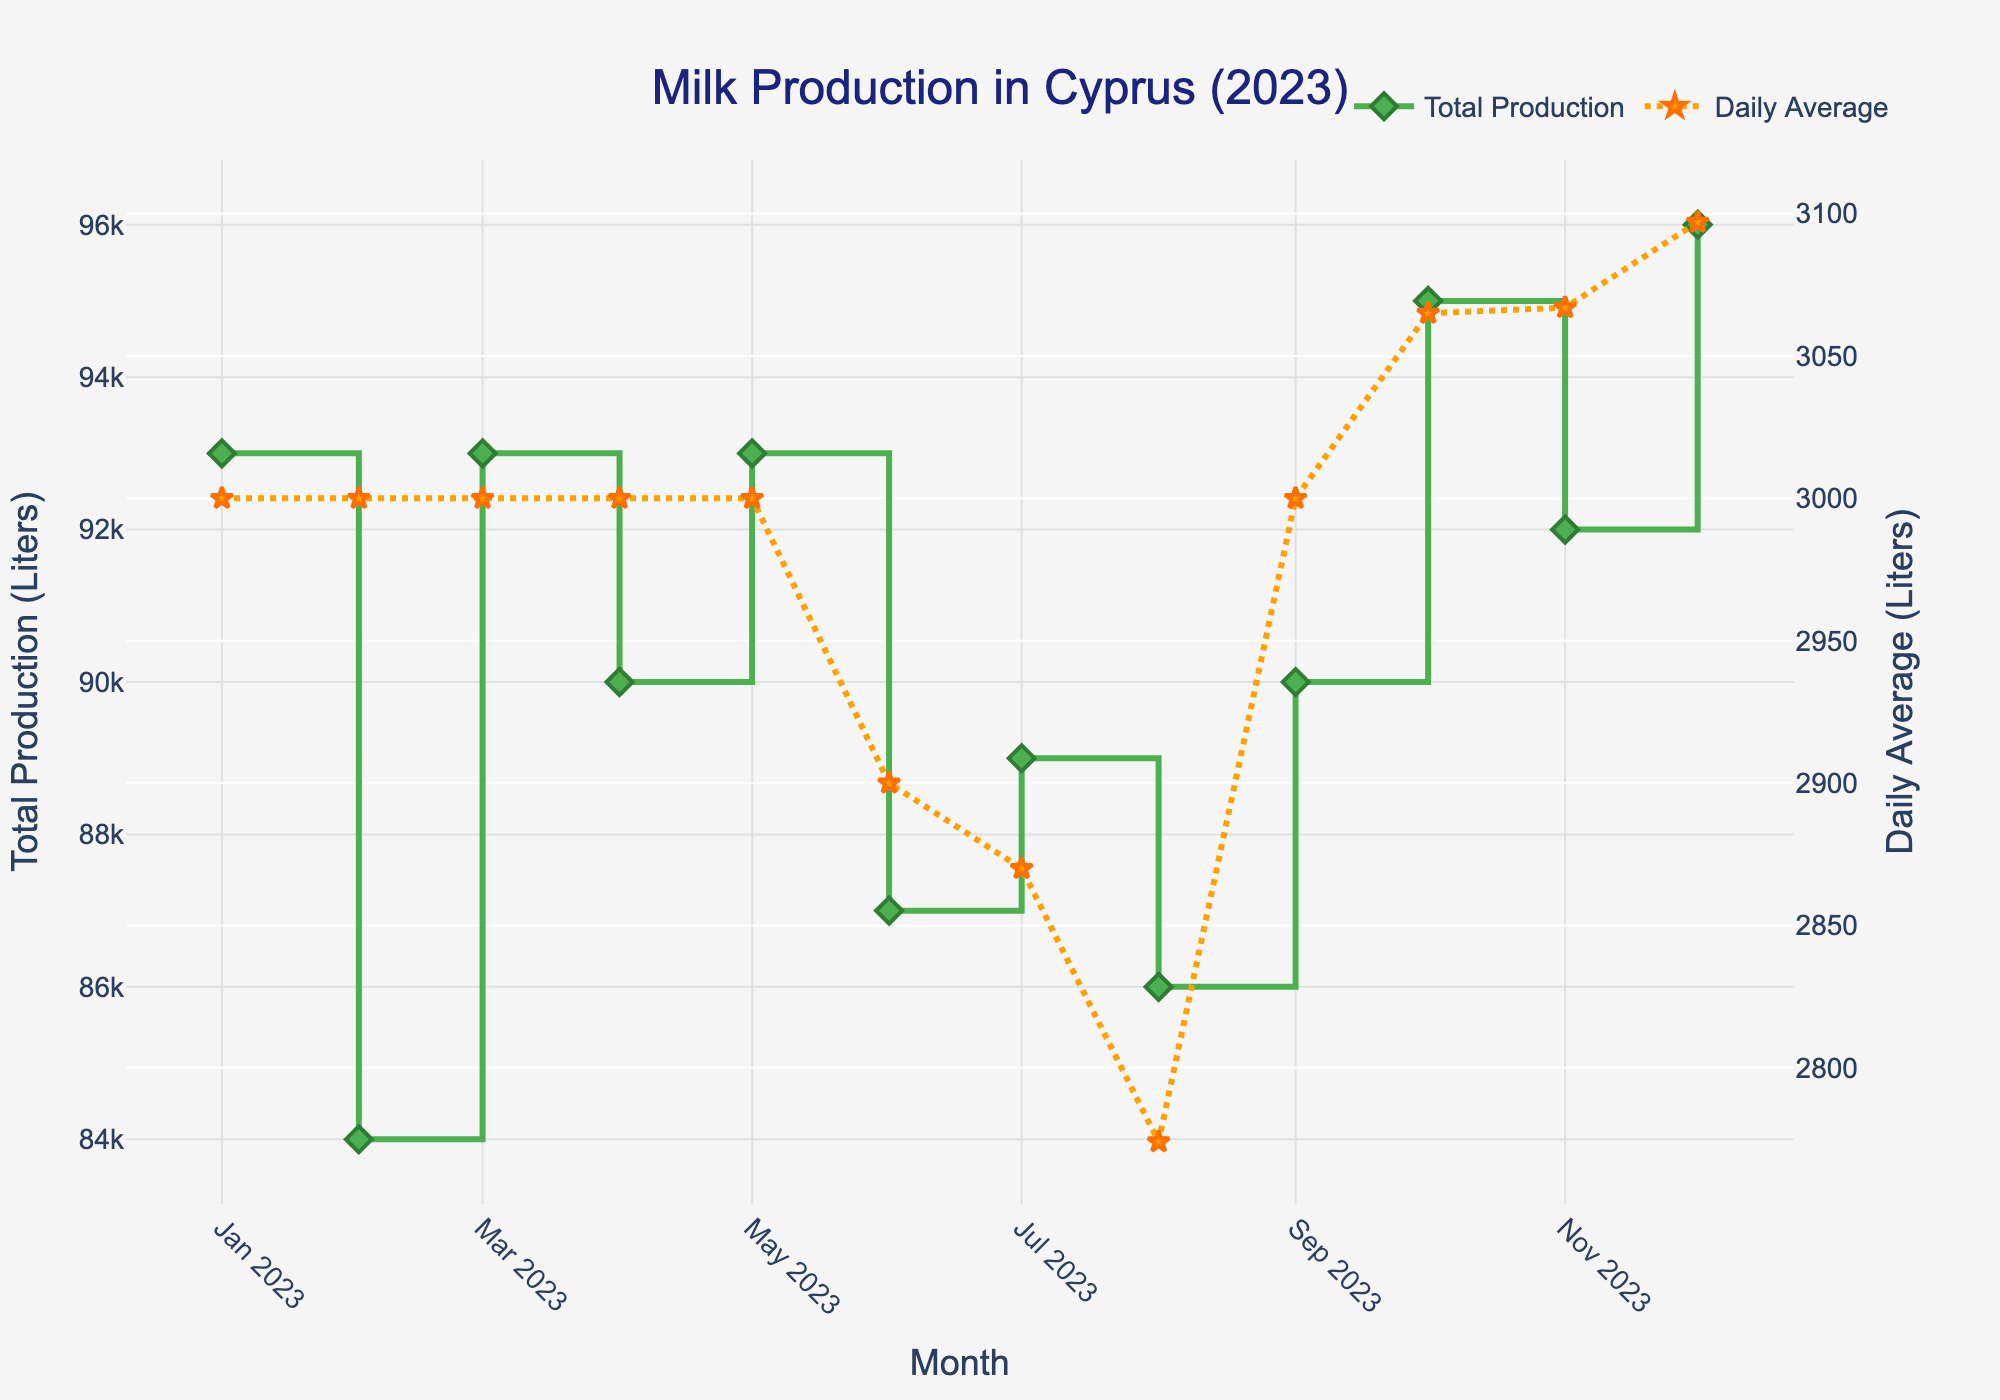What is the title of the plot? The title is usually displayed at the top of the plot. It provides a summary of what the plot is about.
Answer: Milk Production in Cyprus (2023) How many data points are there in the plot? Each data point corresponds to a month, so we count the number of months on the x-axis.
Answer: 12 What month had the highest Total Milk Production? Identify the highest point on the green "Total Production" line and refer to the corresponding month on the x-axis.
Answer: December Which month had the lowest Daily Average? Locate the lowest point on the orange "Daily Average" line and see which month it aligns with on the x-axis.
Answer: August What is the Daily Average for June? Find the June data point on the orange "Daily Average" line and read its value on the secondary y-axis.
Answer: 2900 liters Compare the Total Milk Production between January and December. Look at the green "Total Production" line for both January and December. The higher value indicates greater production. December’s value is higher than January's.
Answer: December has higher Total Production than January Calculate the difference in Total Milk Production between February and March. Read the Total Milk Production values for February and March from the green line. Subtract February's value from March's value.
Answer: 93000 - 84000 = 9000 liters Which months have a Daily Average above 3000 liters? Identify parts of the orange "Daily Average" line that are above the 3000 liters mark and note the corresponding months.
Answer: October, November, December How does the Daily Average change from July to August? Observe the orange "Daily Average" line between July and August. Determine if the line goes up or down.
Answer: It decreases Explain the trend in Total Milk Production from June to August. Look at the green "Total Production" line from June to August and describe its behavior (e.g., whether it goes up, down, or remains stable).
Answer: The trend is decreasing: June and August show lower production than previous months 